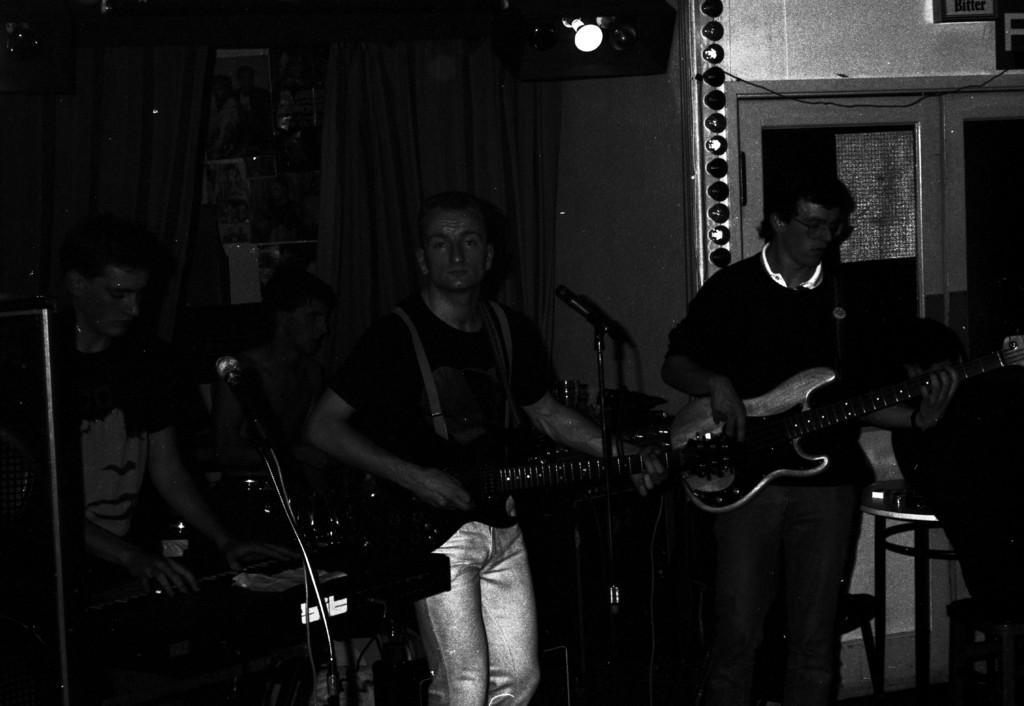Can you describe this image briefly? There are four members in this picture. Two of them were playing guitars in their hands in front of a mic. One of the guy is playing a piano and sitting in front of it. In the background there is a woman sitting. We can observe some curtains and a shelf here. 